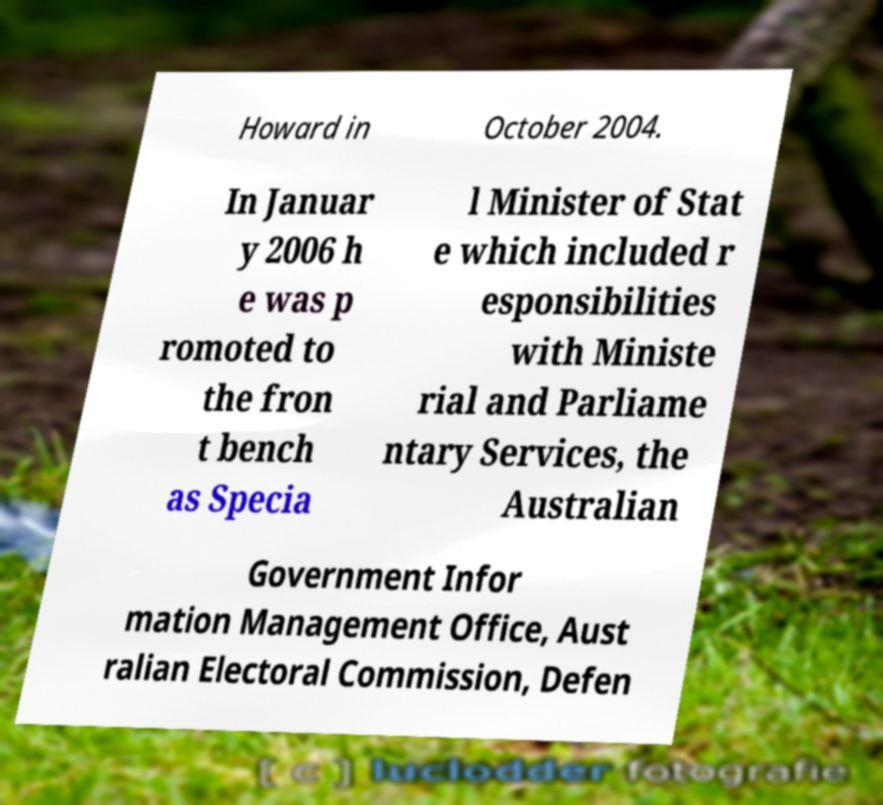What messages or text are displayed in this image? I need them in a readable, typed format. Howard in October 2004. In Januar y 2006 h e was p romoted to the fron t bench as Specia l Minister of Stat e which included r esponsibilities with Ministe rial and Parliame ntary Services, the Australian Government Infor mation Management Office, Aust ralian Electoral Commission, Defen 